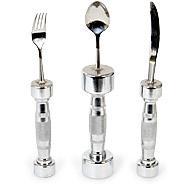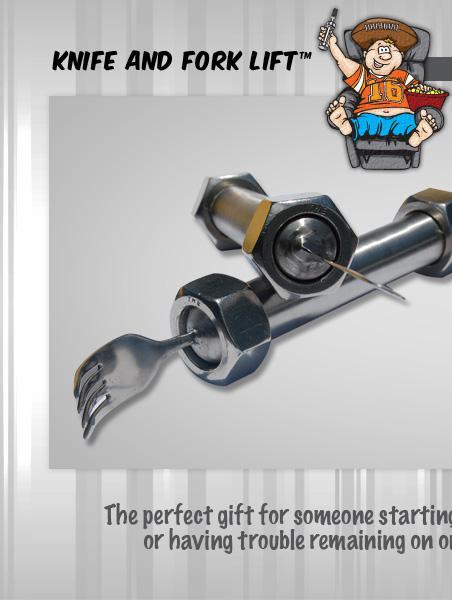The first image is the image on the left, the second image is the image on the right. For the images displayed, is the sentence "One image shows a matched set of knife, fork, and spoon utensils." factually correct? Answer yes or no. Yes. 